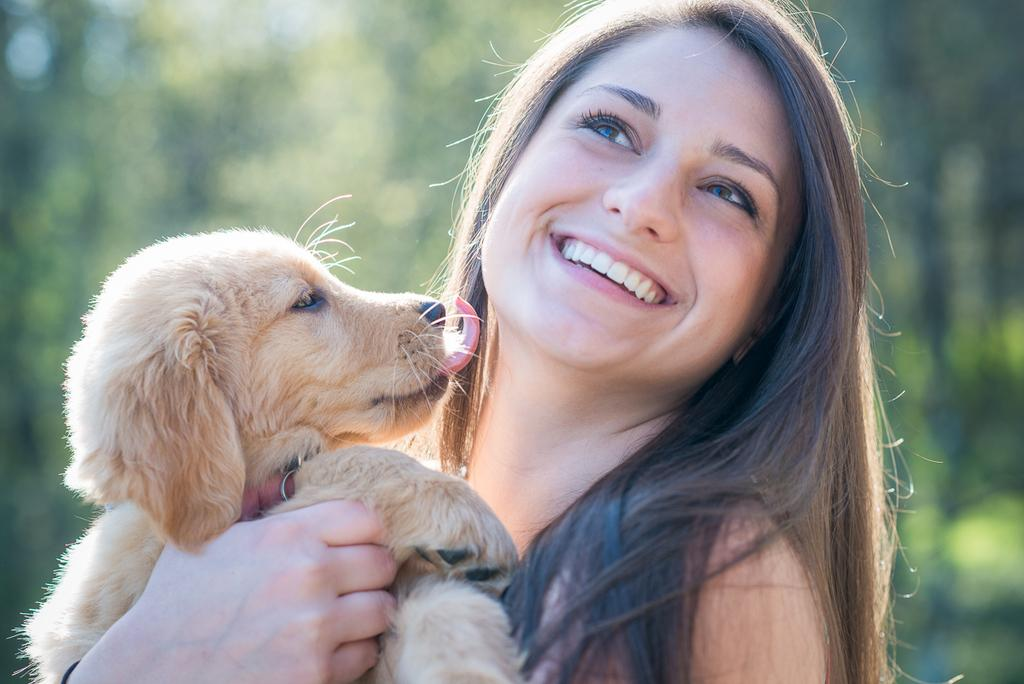Who is present in the image? A: There is a woman in the image. What is the woman doing in the image? The woman is standing and smiling. What is the woman holding in the image? The woman is holding a puppy. What can be observed about the background of the image? The background has a light green color. What type of clocks can be seen hanging on the wall in the image? There are no clocks visible in the image. What is the nature of the love depicted in the image? The image does not depict any love or romantic relationship; it features a woman holding a puppy. 